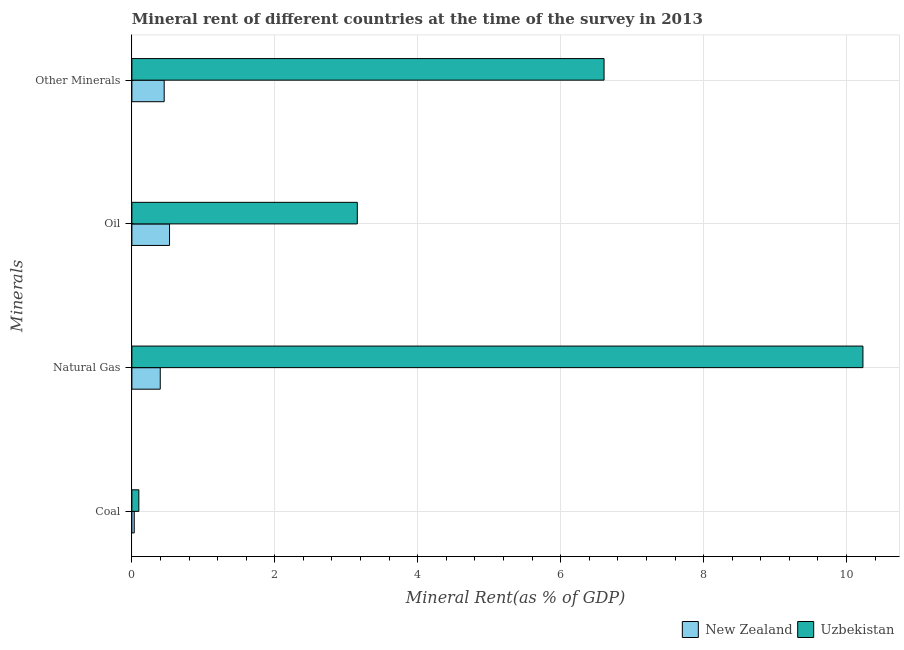Are the number of bars on each tick of the Y-axis equal?
Provide a succinct answer. Yes. How many bars are there on the 2nd tick from the top?
Offer a very short reply. 2. How many bars are there on the 1st tick from the bottom?
Offer a terse response. 2. What is the label of the 4th group of bars from the top?
Give a very brief answer. Coal. What is the coal rent in Uzbekistan?
Make the answer very short. 0.1. Across all countries, what is the maximum  rent of other minerals?
Offer a terse response. 6.61. Across all countries, what is the minimum oil rent?
Provide a short and direct response. 0.53. In which country was the natural gas rent maximum?
Keep it short and to the point. Uzbekistan. In which country was the  rent of other minerals minimum?
Ensure brevity in your answer.  New Zealand. What is the total natural gas rent in the graph?
Provide a succinct answer. 10.63. What is the difference between the oil rent in Uzbekistan and that in New Zealand?
Provide a succinct answer. 2.63. What is the difference between the  rent of other minerals in Uzbekistan and the coal rent in New Zealand?
Your answer should be compact. 6.57. What is the average oil rent per country?
Your response must be concise. 1.84. What is the difference between the oil rent and natural gas rent in New Zealand?
Offer a very short reply. 0.13. What is the ratio of the natural gas rent in New Zealand to that in Uzbekistan?
Give a very brief answer. 0.04. Is the  rent of other minerals in Uzbekistan less than that in New Zealand?
Provide a short and direct response. No. What is the difference between the highest and the second highest oil rent?
Give a very brief answer. 2.63. What is the difference between the highest and the lowest natural gas rent?
Your answer should be very brief. 9.83. In how many countries, is the natural gas rent greater than the average natural gas rent taken over all countries?
Your response must be concise. 1. Is the sum of the oil rent in Uzbekistan and New Zealand greater than the maximum  rent of other minerals across all countries?
Ensure brevity in your answer.  No. What does the 1st bar from the top in Oil represents?
Keep it short and to the point. Uzbekistan. What does the 1st bar from the bottom in Coal represents?
Your answer should be compact. New Zealand. How many bars are there?
Keep it short and to the point. 8. Are all the bars in the graph horizontal?
Offer a terse response. Yes. How many countries are there in the graph?
Keep it short and to the point. 2. What is the difference between two consecutive major ticks on the X-axis?
Give a very brief answer. 2. Does the graph contain grids?
Make the answer very short. Yes. How many legend labels are there?
Keep it short and to the point. 2. What is the title of the graph?
Offer a very short reply. Mineral rent of different countries at the time of the survey in 2013. Does "Serbia" appear as one of the legend labels in the graph?
Provide a short and direct response. No. What is the label or title of the X-axis?
Your response must be concise. Mineral Rent(as % of GDP). What is the label or title of the Y-axis?
Provide a short and direct response. Minerals. What is the Mineral Rent(as % of GDP) in New Zealand in Coal?
Your answer should be very brief. 0.03. What is the Mineral Rent(as % of GDP) in Uzbekistan in Coal?
Make the answer very short. 0.1. What is the Mineral Rent(as % of GDP) in New Zealand in Natural Gas?
Offer a very short reply. 0.4. What is the Mineral Rent(as % of GDP) of Uzbekistan in Natural Gas?
Provide a succinct answer. 10.23. What is the Mineral Rent(as % of GDP) in New Zealand in Oil?
Provide a short and direct response. 0.53. What is the Mineral Rent(as % of GDP) in Uzbekistan in Oil?
Ensure brevity in your answer.  3.15. What is the Mineral Rent(as % of GDP) of New Zealand in Other Minerals?
Provide a succinct answer. 0.45. What is the Mineral Rent(as % of GDP) of Uzbekistan in Other Minerals?
Offer a terse response. 6.61. Across all Minerals, what is the maximum Mineral Rent(as % of GDP) in New Zealand?
Give a very brief answer. 0.53. Across all Minerals, what is the maximum Mineral Rent(as % of GDP) of Uzbekistan?
Make the answer very short. 10.23. Across all Minerals, what is the minimum Mineral Rent(as % of GDP) of New Zealand?
Give a very brief answer. 0.03. Across all Minerals, what is the minimum Mineral Rent(as % of GDP) of Uzbekistan?
Your answer should be very brief. 0.1. What is the total Mineral Rent(as % of GDP) in New Zealand in the graph?
Ensure brevity in your answer.  1.41. What is the total Mineral Rent(as % of GDP) in Uzbekistan in the graph?
Give a very brief answer. 20.09. What is the difference between the Mineral Rent(as % of GDP) in New Zealand in Coal and that in Natural Gas?
Your response must be concise. -0.36. What is the difference between the Mineral Rent(as % of GDP) of Uzbekistan in Coal and that in Natural Gas?
Your answer should be compact. -10.13. What is the difference between the Mineral Rent(as % of GDP) in New Zealand in Coal and that in Oil?
Provide a succinct answer. -0.49. What is the difference between the Mineral Rent(as % of GDP) of Uzbekistan in Coal and that in Oil?
Provide a short and direct response. -3.06. What is the difference between the Mineral Rent(as % of GDP) of New Zealand in Coal and that in Other Minerals?
Give a very brief answer. -0.42. What is the difference between the Mineral Rent(as % of GDP) of Uzbekistan in Coal and that in Other Minerals?
Provide a short and direct response. -6.51. What is the difference between the Mineral Rent(as % of GDP) in New Zealand in Natural Gas and that in Oil?
Ensure brevity in your answer.  -0.13. What is the difference between the Mineral Rent(as % of GDP) of Uzbekistan in Natural Gas and that in Oil?
Provide a short and direct response. 7.08. What is the difference between the Mineral Rent(as % of GDP) of New Zealand in Natural Gas and that in Other Minerals?
Offer a terse response. -0.06. What is the difference between the Mineral Rent(as % of GDP) in Uzbekistan in Natural Gas and that in Other Minerals?
Ensure brevity in your answer.  3.62. What is the difference between the Mineral Rent(as % of GDP) of New Zealand in Oil and that in Other Minerals?
Your response must be concise. 0.07. What is the difference between the Mineral Rent(as % of GDP) in Uzbekistan in Oil and that in Other Minerals?
Give a very brief answer. -3.45. What is the difference between the Mineral Rent(as % of GDP) in New Zealand in Coal and the Mineral Rent(as % of GDP) in Uzbekistan in Natural Gas?
Give a very brief answer. -10.2. What is the difference between the Mineral Rent(as % of GDP) of New Zealand in Coal and the Mineral Rent(as % of GDP) of Uzbekistan in Oil?
Your answer should be very brief. -3.12. What is the difference between the Mineral Rent(as % of GDP) of New Zealand in Coal and the Mineral Rent(as % of GDP) of Uzbekistan in Other Minerals?
Offer a terse response. -6.57. What is the difference between the Mineral Rent(as % of GDP) of New Zealand in Natural Gas and the Mineral Rent(as % of GDP) of Uzbekistan in Oil?
Ensure brevity in your answer.  -2.76. What is the difference between the Mineral Rent(as % of GDP) in New Zealand in Natural Gas and the Mineral Rent(as % of GDP) in Uzbekistan in Other Minerals?
Provide a short and direct response. -6.21. What is the difference between the Mineral Rent(as % of GDP) of New Zealand in Oil and the Mineral Rent(as % of GDP) of Uzbekistan in Other Minerals?
Provide a succinct answer. -6.08. What is the average Mineral Rent(as % of GDP) in New Zealand per Minerals?
Your response must be concise. 0.35. What is the average Mineral Rent(as % of GDP) in Uzbekistan per Minerals?
Provide a short and direct response. 5.02. What is the difference between the Mineral Rent(as % of GDP) in New Zealand and Mineral Rent(as % of GDP) in Uzbekistan in Coal?
Provide a short and direct response. -0.06. What is the difference between the Mineral Rent(as % of GDP) in New Zealand and Mineral Rent(as % of GDP) in Uzbekistan in Natural Gas?
Make the answer very short. -9.83. What is the difference between the Mineral Rent(as % of GDP) of New Zealand and Mineral Rent(as % of GDP) of Uzbekistan in Oil?
Keep it short and to the point. -2.63. What is the difference between the Mineral Rent(as % of GDP) of New Zealand and Mineral Rent(as % of GDP) of Uzbekistan in Other Minerals?
Ensure brevity in your answer.  -6.16. What is the ratio of the Mineral Rent(as % of GDP) of New Zealand in Coal to that in Natural Gas?
Make the answer very short. 0.08. What is the ratio of the Mineral Rent(as % of GDP) in Uzbekistan in Coal to that in Natural Gas?
Your answer should be very brief. 0.01. What is the ratio of the Mineral Rent(as % of GDP) of New Zealand in Coal to that in Oil?
Offer a very short reply. 0.06. What is the ratio of the Mineral Rent(as % of GDP) in Uzbekistan in Coal to that in Oil?
Provide a short and direct response. 0.03. What is the ratio of the Mineral Rent(as % of GDP) in New Zealand in Coal to that in Other Minerals?
Your answer should be compact. 0.07. What is the ratio of the Mineral Rent(as % of GDP) of Uzbekistan in Coal to that in Other Minerals?
Ensure brevity in your answer.  0.01. What is the ratio of the Mineral Rent(as % of GDP) in New Zealand in Natural Gas to that in Oil?
Your answer should be very brief. 0.75. What is the ratio of the Mineral Rent(as % of GDP) of Uzbekistan in Natural Gas to that in Oil?
Keep it short and to the point. 3.24. What is the ratio of the Mineral Rent(as % of GDP) of New Zealand in Natural Gas to that in Other Minerals?
Your response must be concise. 0.88. What is the ratio of the Mineral Rent(as % of GDP) of Uzbekistan in Natural Gas to that in Other Minerals?
Your answer should be very brief. 1.55. What is the ratio of the Mineral Rent(as % of GDP) of New Zealand in Oil to that in Other Minerals?
Make the answer very short. 1.17. What is the ratio of the Mineral Rent(as % of GDP) of Uzbekistan in Oil to that in Other Minerals?
Keep it short and to the point. 0.48. What is the difference between the highest and the second highest Mineral Rent(as % of GDP) of New Zealand?
Offer a terse response. 0.07. What is the difference between the highest and the second highest Mineral Rent(as % of GDP) of Uzbekistan?
Your answer should be very brief. 3.62. What is the difference between the highest and the lowest Mineral Rent(as % of GDP) in New Zealand?
Provide a succinct answer. 0.49. What is the difference between the highest and the lowest Mineral Rent(as % of GDP) of Uzbekistan?
Your answer should be very brief. 10.13. 